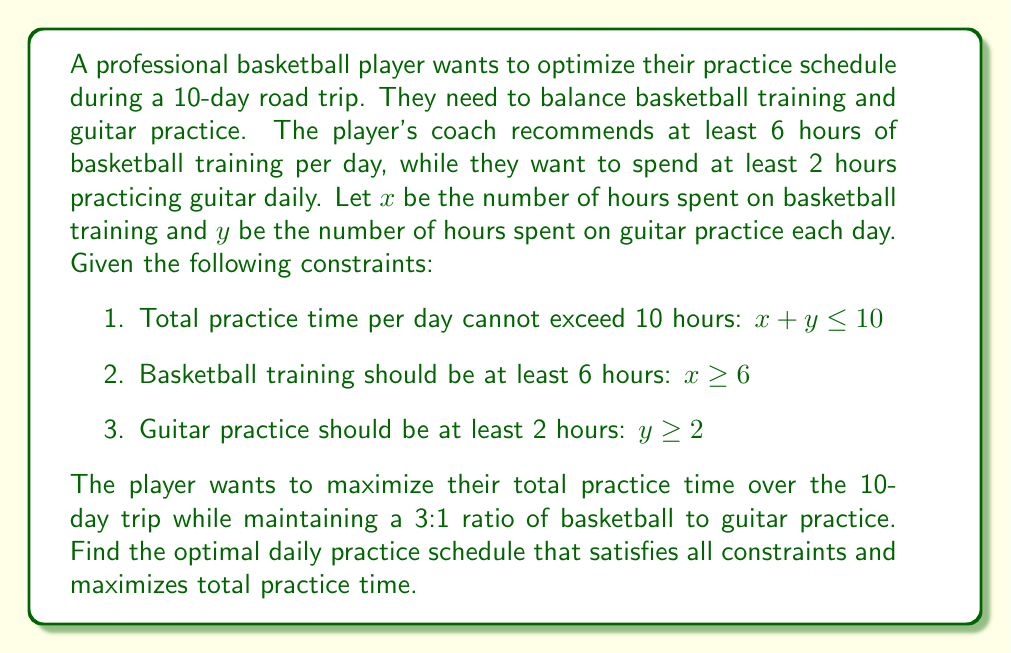Show me your answer to this math problem. Let's approach this step-by-step:

1) First, we need to set up our objective function. We want to maximize the total practice time, which is $x + y$.

2) We also need to incorporate the 3:1 ratio of basketball to guitar practice. This can be expressed as:

   $$ x = 3y $$

3) Now, let's list our constraints:
   $$ x + y \leq 10 $$
   $$ x \geq 6 $$
   $$ y \geq 2 $$

4) Substituting $x = 3y$ into the first constraint:
   $$ 3y + y \leq 10 $$
   $$ 4y \leq 10 $$
   $$ y \leq 2.5 $$

5) From the third constraint, we know $y \geq 2$. Combining this with $y \leq 2.5$, we get:
   $$ 2 \leq y \leq 2.5 $$

6) Since we want to maximize practice time, we should choose the largest possible value for $y$, which is 2.5.

7) If $y = 2.5$, then $x = 3y = 3(2.5) = 7.5$

8) We need to check if this satisfies all constraints:
   - $x + y = 7.5 + 2.5 = 10 \leq 10$ (satisfies)
   - $x = 7.5 \geq 6$ (satisfies)
   - $y = 2.5 \geq 2$ (satisfies)

Therefore, the optimal daily practice schedule is 7.5 hours of basketball training and 2.5 hours of guitar practice.
Answer: The optimal daily practice schedule is 7.5 hours of basketball training and 2.5 hours of guitar practice. 